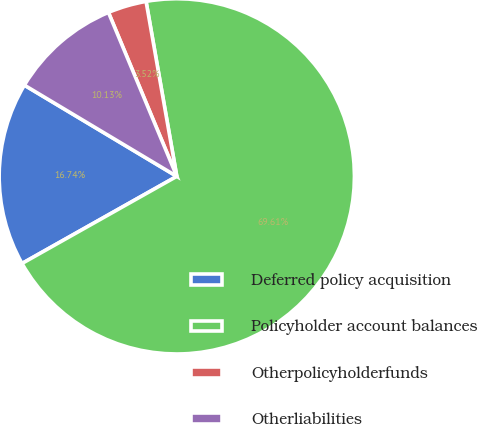Convert chart to OTSL. <chart><loc_0><loc_0><loc_500><loc_500><pie_chart><fcel>Deferred policy acquisition<fcel>Policyholder account balances<fcel>Otherpolicyholderfunds<fcel>Otherliabilities<nl><fcel>16.74%<fcel>69.6%<fcel>3.52%<fcel>10.13%<nl></chart> 